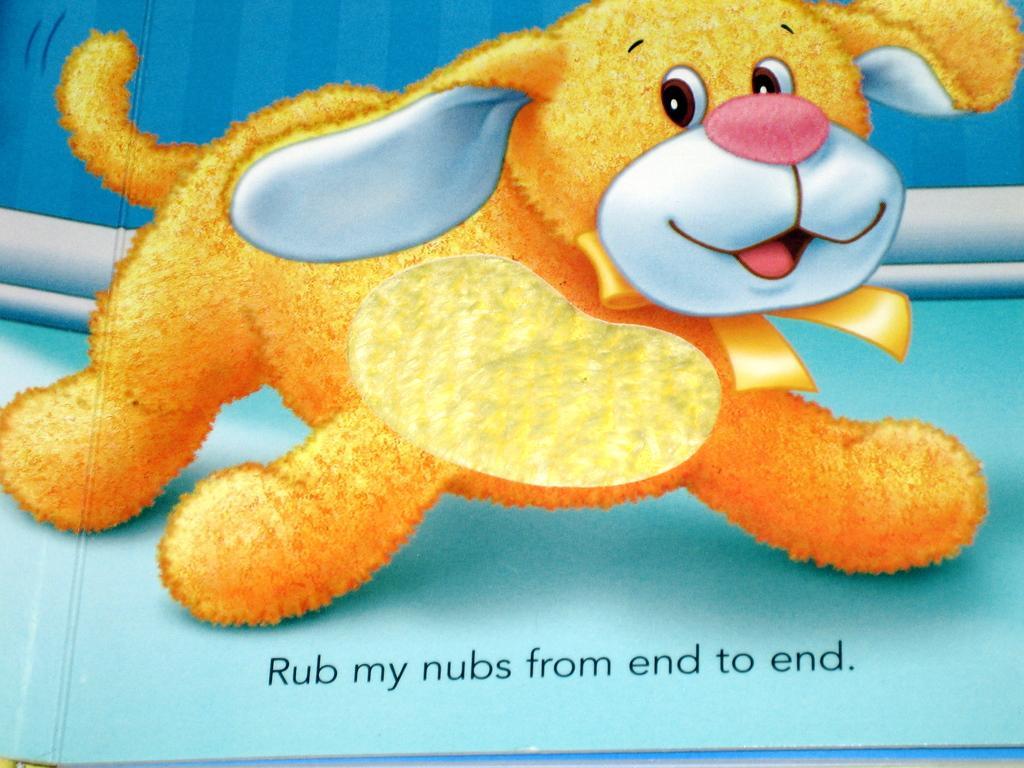Describe this image in one or two sentences. In this image I see the depiction of a dog and I see something is written over here and I see the blue color surface and white and blue color background. 